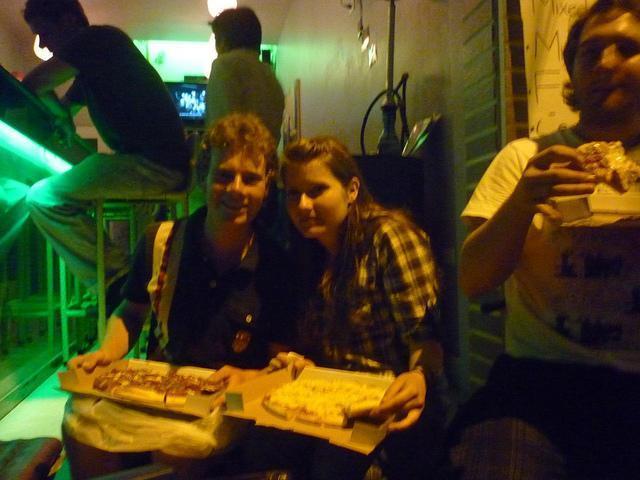How many people are in the photo?
Give a very brief answer. 5. How many people can you see?
Give a very brief answer. 5. How many chairs are there?
Give a very brief answer. 1. How many pizzas are there?
Give a very brief answer. 2. 